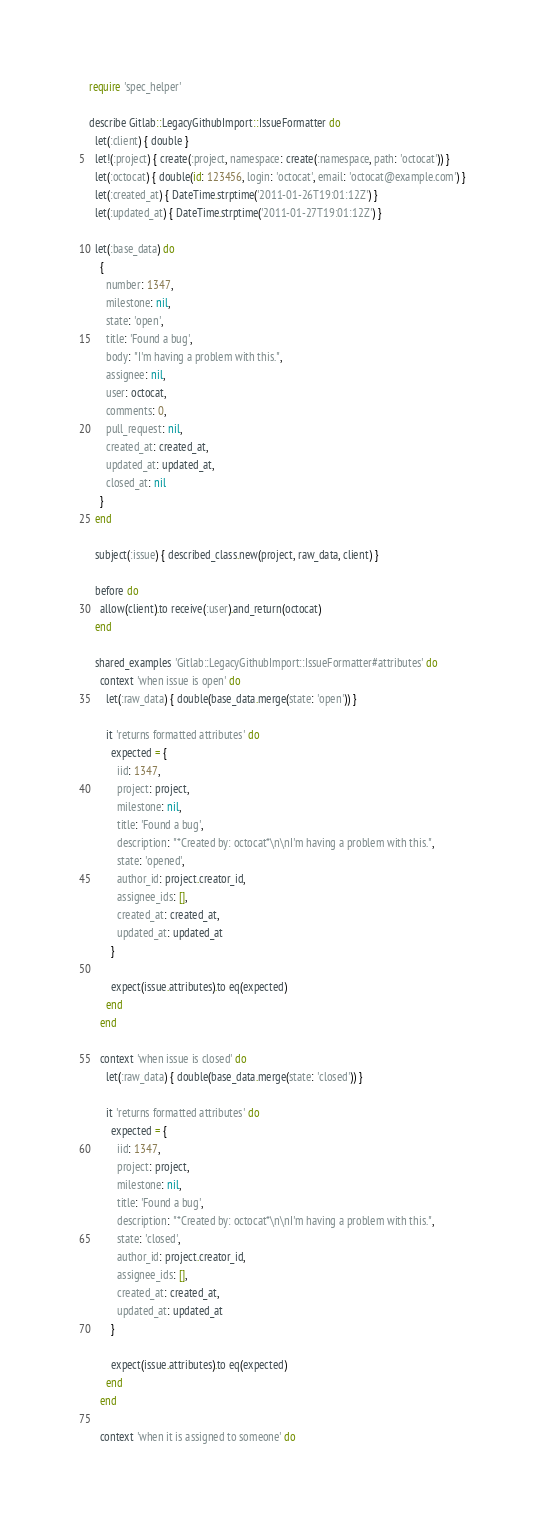Convert code to text. <code><loc_0><loc_0><loc_500><loc_500><_Ruby_>require 'spec_helper'

describe Gitlab::LegacyGithubImport::IssueFormatter do
  let(:client) { double }
  let!(:project) { create(:project, namespace: create(:namespace, path: 'octocat')) }
  let(:octocat) { double(id: 123456, login: 'octocat', email: 'octocat@example.com') }
  let(:created_at) { DateTime.strptime('2011-01-26T19:01:12Z') }
  let(:updated_at) { DateTime.strptime('2011-01-27T19:01:12Z') }

  let(:base_data) do
    {
      number: 1347,
      milestone: nil,
      state: 'open',
      title: 'Found a bug',
      body: "I'm having a problem with this.",
      assignee: nil,
      user: octocat,
      comments: 0,
      pull_request: nil,
      created_at: created_at,
      updated_at: updated_at,
      closed_at: nil
    }
  end

  subject(:issue) { described_class.new(project, raw_data, client) }

  before do
    allow(client).to receive(:user).and_return(octocat)
  end

  shared_examples 'Gitlab::LegacyGithubImport::IssueFormatter#attributes' do
    context 'when issue is open' do
      let(:raw_data) { double(base_data.merge(state: 'open')) }

      it 'returns formatted attributes' do
        expected = {
          iid: 1347,
          project: project,
          milestone: nil,
          title: 'Found a bug',
          description: "*Created by: octocat*\n\nI'm having a problem with this.",
          state: 'opened',
          author_id: project.creator_id,
          assignee_ids: [],
          created_at: created_at,
          updated_at: updated_at
        }

        expect(issue.attributes).to eq(expected)
      end
    end

    context 'when issue is closed' do
      let(:raw_data) { double(base_data.merge(state: 'closed')) }

      it 'returns formatted attributes' do
        expected = {
          iid: 1347,
          project: project,
          milestone: nil,
          title: 'Found a bug',
          description: "*Created by: octocat*\n\nI'm having a problem with this.",
          state: 'closed',
          author_id: project.creator_id,
          assignee_ids: [],
          created_at: created_at,
          updated_at: updated_at
        }

        expect(issue.attributes).to eq(expected)
      end
    end

    context 'when it is assigned to someone' do</code> 